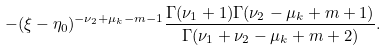<formula> <loc_0><loc_0><loc_500><loc_500>- ( \xi - \eta _ { 0 } ) ^ { - \nu _ { 2 } + \mu _ { k } - m - 1 } \frac { \Gamma ( \nu _ { 1 } + 1 ) \Gamma ( \nu _ { 2 } - \mu _ { k } + m + 1 ) } { \Gamma ( \nu _ { 1 } + \nu _ { 2 } - \mu _ { k } + m + 2 ) } .</formula> 